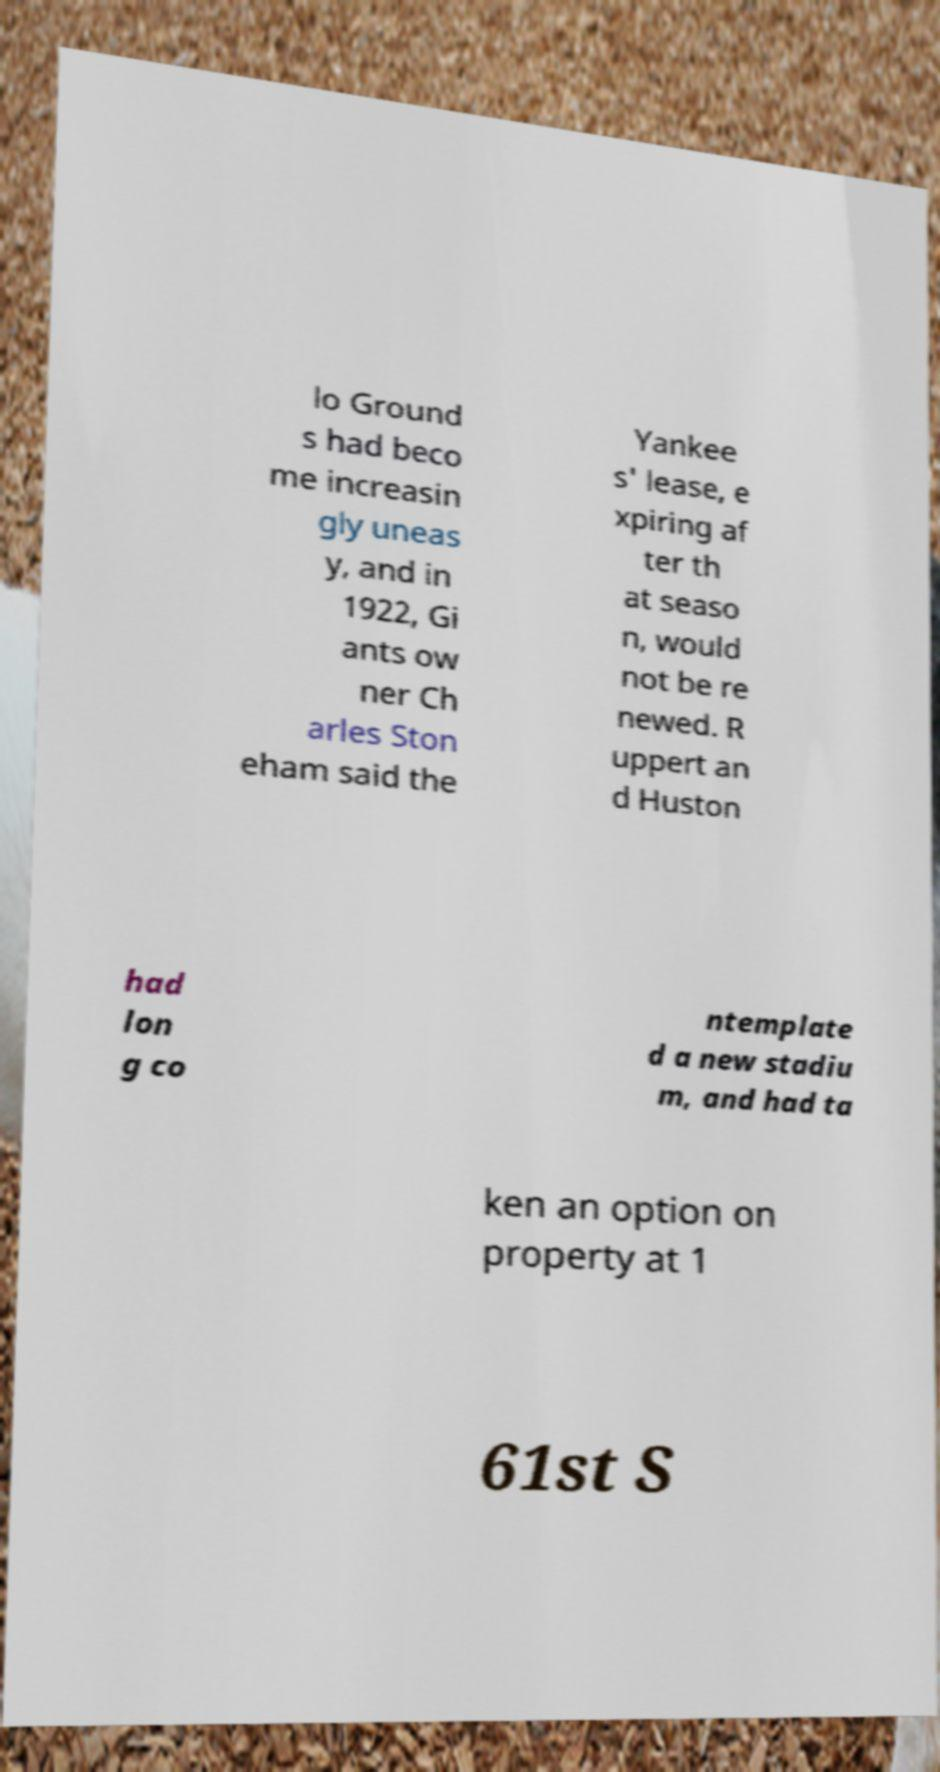What messages or text are displayed in this image? I need them in a readable, typed format. lo Ground s had beco me increasin gly uneas y, and in 1922, Gi ants ow ner Ch arles Ston eham said the Yankee s' lease, e xpiring af ter th at seaso n, would not be re newed. R uppert an d Huston had lon g co ntemplate d a new stadiu m, and had ta ken an option on property at 1 61st S 